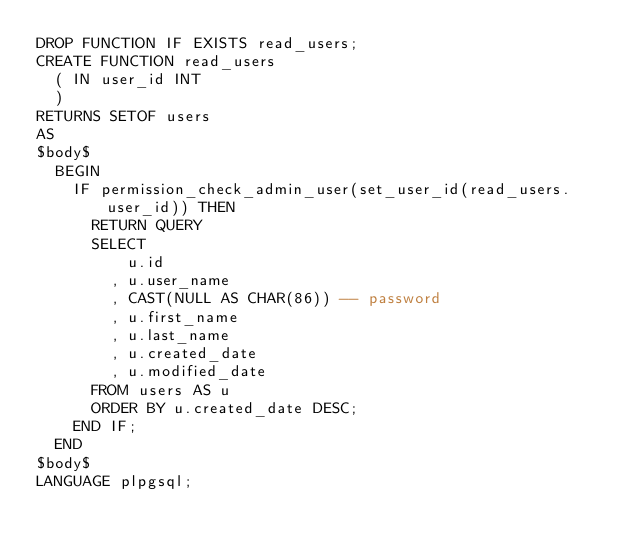<code> <loc_0><loc_0><loc_500><loc_500><_SQL_>DROP FUNCTION IF EXISTS read_users;
CREATE FUNCTION read_users
	( IN user_id INT
	)
RETURNS SETOF users
AS
$body$
	BEGIN
		IF permission_check_admin_user(set_user_id(read_users.user_id)) THEN
			RETURN QUERY
			SELECT
				  u.id
				, u.user_name
				, CAST(NULL AS CHAR(86)) -- password
				, u.first_name
				, u.last_name
				, u.created_date
				, u.modified_date
			FROM users AS u
			ORDER BY u.created_date DESC;
		END IF;
	END
$body$
LANGUAGE plpgsql;
</code> 